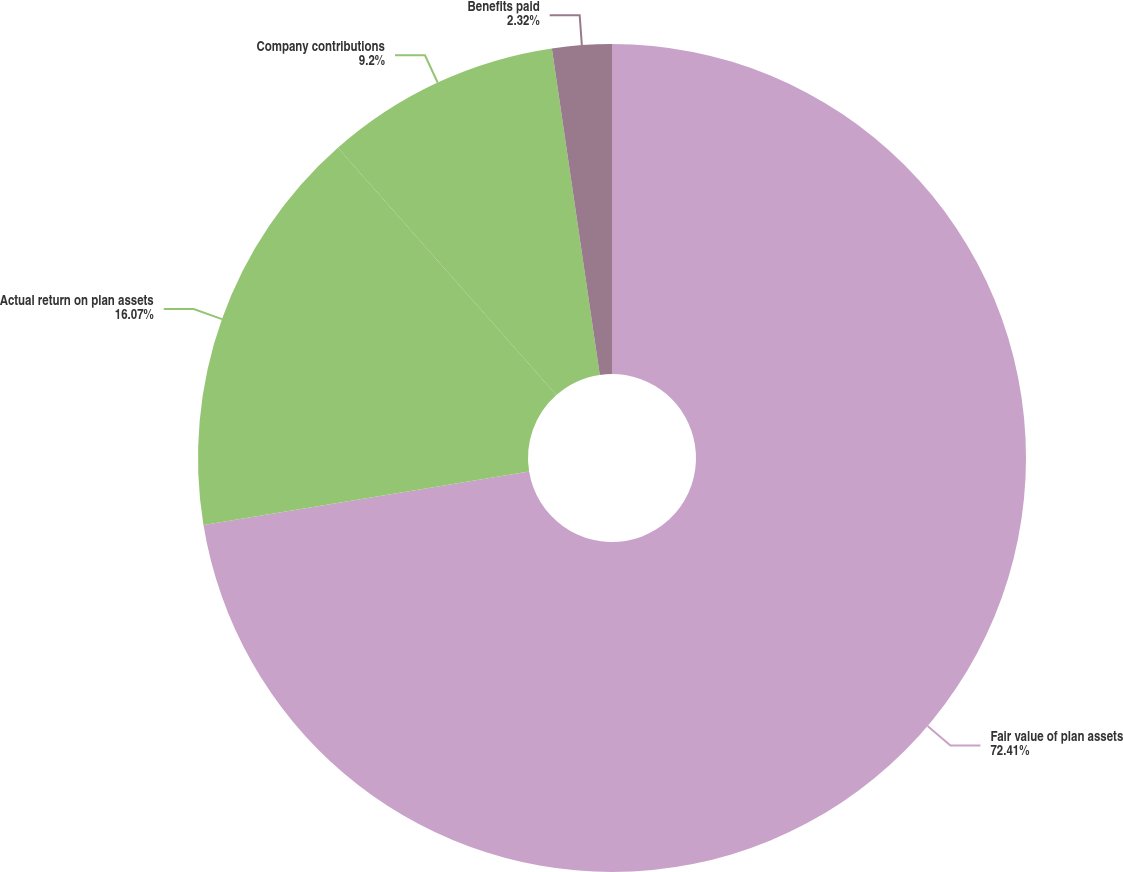Convert chart to OTSL. <chart><loc_0><loc_0><loc_500><loc_500><pie_chart><fcel>Fair value of plan assets<fcel>Actual return on plan assets<fcel>Company contributions<fcel>Benefits paid<nl><fcel>72.41%<fcel>16.07%<fcel>9.2%<fcel>2.32%<nl></chart> 